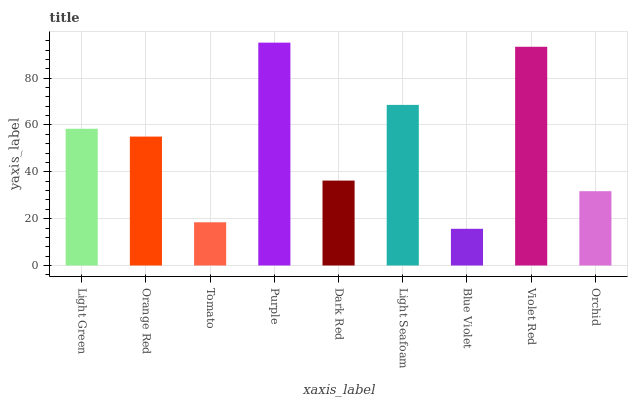Is Blue Violet the minimum?
Answer yes or no. Yes. Is Purple the maximum?
Answer yes or no. Yes. Is Orange Red the minimum?
Answer yes or no. No. Is Orange Red the maximum?
Answer yes or no. No. Is Light Green greater than Orange Red?
Answer yes or no. Yes. Is Orange Red less than Light Green?
Answer yes or no. Yes. Is Orange Red greater than Light Green?
Answer yes or no. No. Is Light Green less than Orange Red?
Answer yes or no. No. Is Orange Red the high median?
Answer yes or no. Yes. Is Orange Red the low median?
Answer yes or no. Yes. Is Tomato the high median?
Answer yes or no. No. Is Tomato the low median?
Answer yes or no. No. 